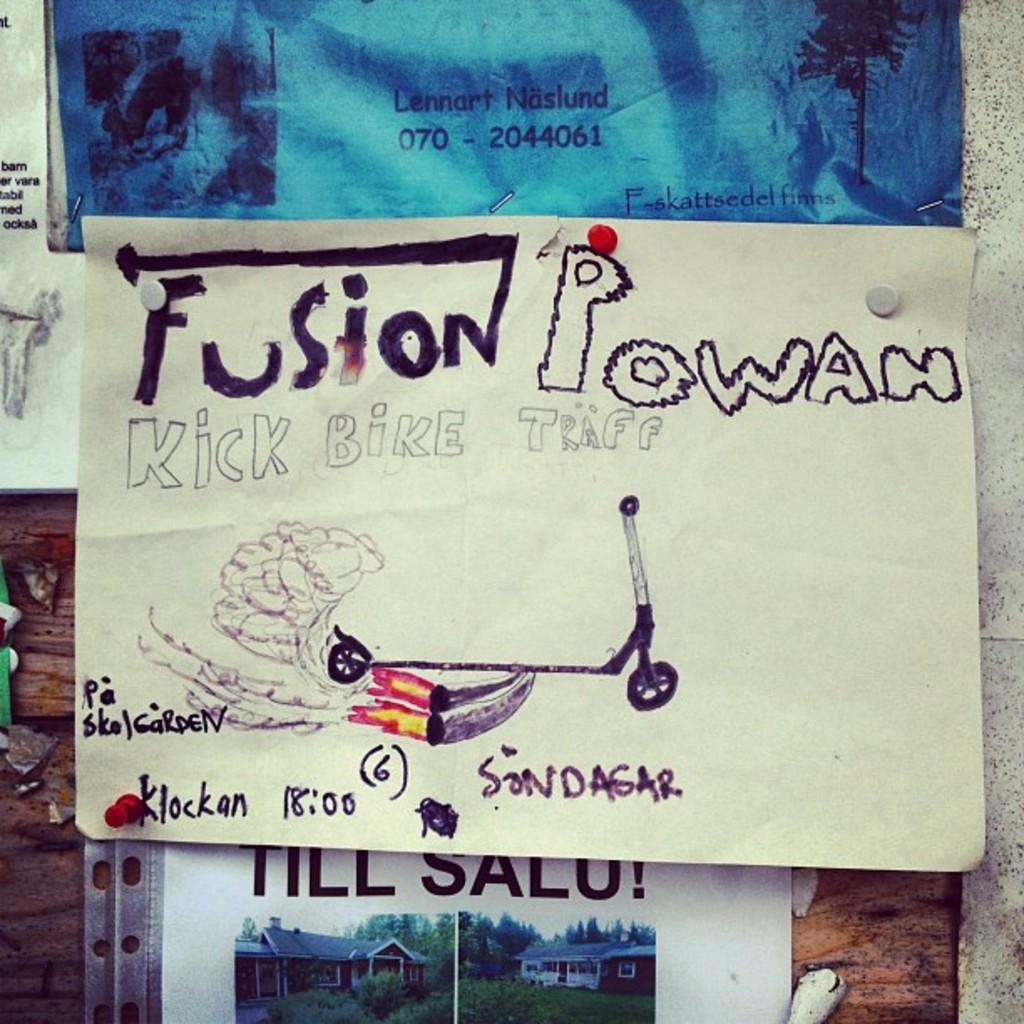What is hanging on the wall in the image? There are posters hanging on the wall in the image. What can be found on the posters? The posters contain text and pictures of objects. How many cats are depicted on the posters in the image? There is no information about cats on the posters in the image. What arithmetic problem is solved on the posters in the image? There is no arithmetic problem present on the posters in the image. 